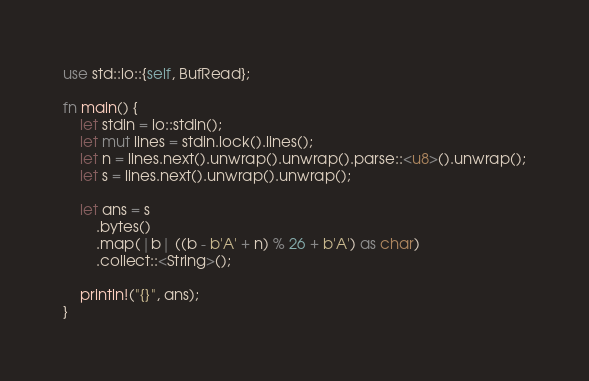Convert code to text. <code><loc_0><loc_0><loc_500><loc_500><_Rust_>use std::io::{self, BufRead};

fn main() {
    let stdin = io::stdin();
    let mut lines = stdin.lock().lines();
    let n = lines.next().unwrap().unwrap().parse::<u8>().unwrap();
    let s = lines.next().unwrap().unwrap();

    let ans = s
        .bytes()
        .map(|b| ((b - b'A' + n) % 26 + b'A') as char)
        .collect::<String>();

    println!("{}", ans);
}
</code> 